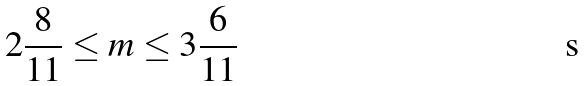<formula> <loc_0><loc_0><loc_500><loc_500>2 \frac { 8 } { 1 1 } \leq m \leq 3 \frac { 6 } { 1 1 }</formula> 